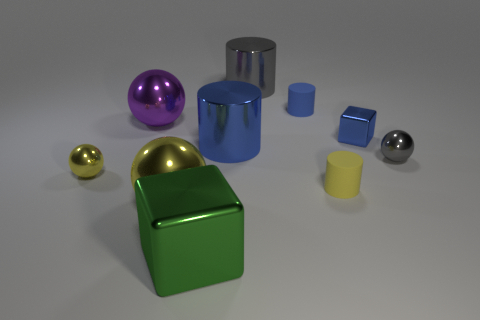The small cylinder in front of the gray metallic sphere is what color?
Give a very brief answer. Yellow. There is a shiny object that is both behind the tiny gray metallic ball and on the left side of the big green object; what is its size?
Provide a short and direct response. Large. Is the tiny yellow cylinder made of the same material as the gray object that is behind the tiny blue block?
Your response must be concise. No. How many other blue metal things are the same shape as the large blue thing?
Ensure brevity in your answer.  0. There is a big object that is the same color as the tiny cube; what is it made of?
Provide a short and direct response. Metal. What number of large blue things are there?
Provide a short and direct response. 1. There is a big purple thing; does it have the same shape as the tiny rubber object in front of the small yellow metallic object?
Make the answer very short. No. What number of objects are large blue cylinders or tiny metal things left of the tiny gray sphere?
Ensure brevity in your answer.  3. What material is the small gray object that is the same shape as the large purple metal object?
Your response must be concise. Metal. There is a object that is behind the blue rubber cylinder; is its shape the same as the tiny gray thing?
Provide a short and direct response. No. 